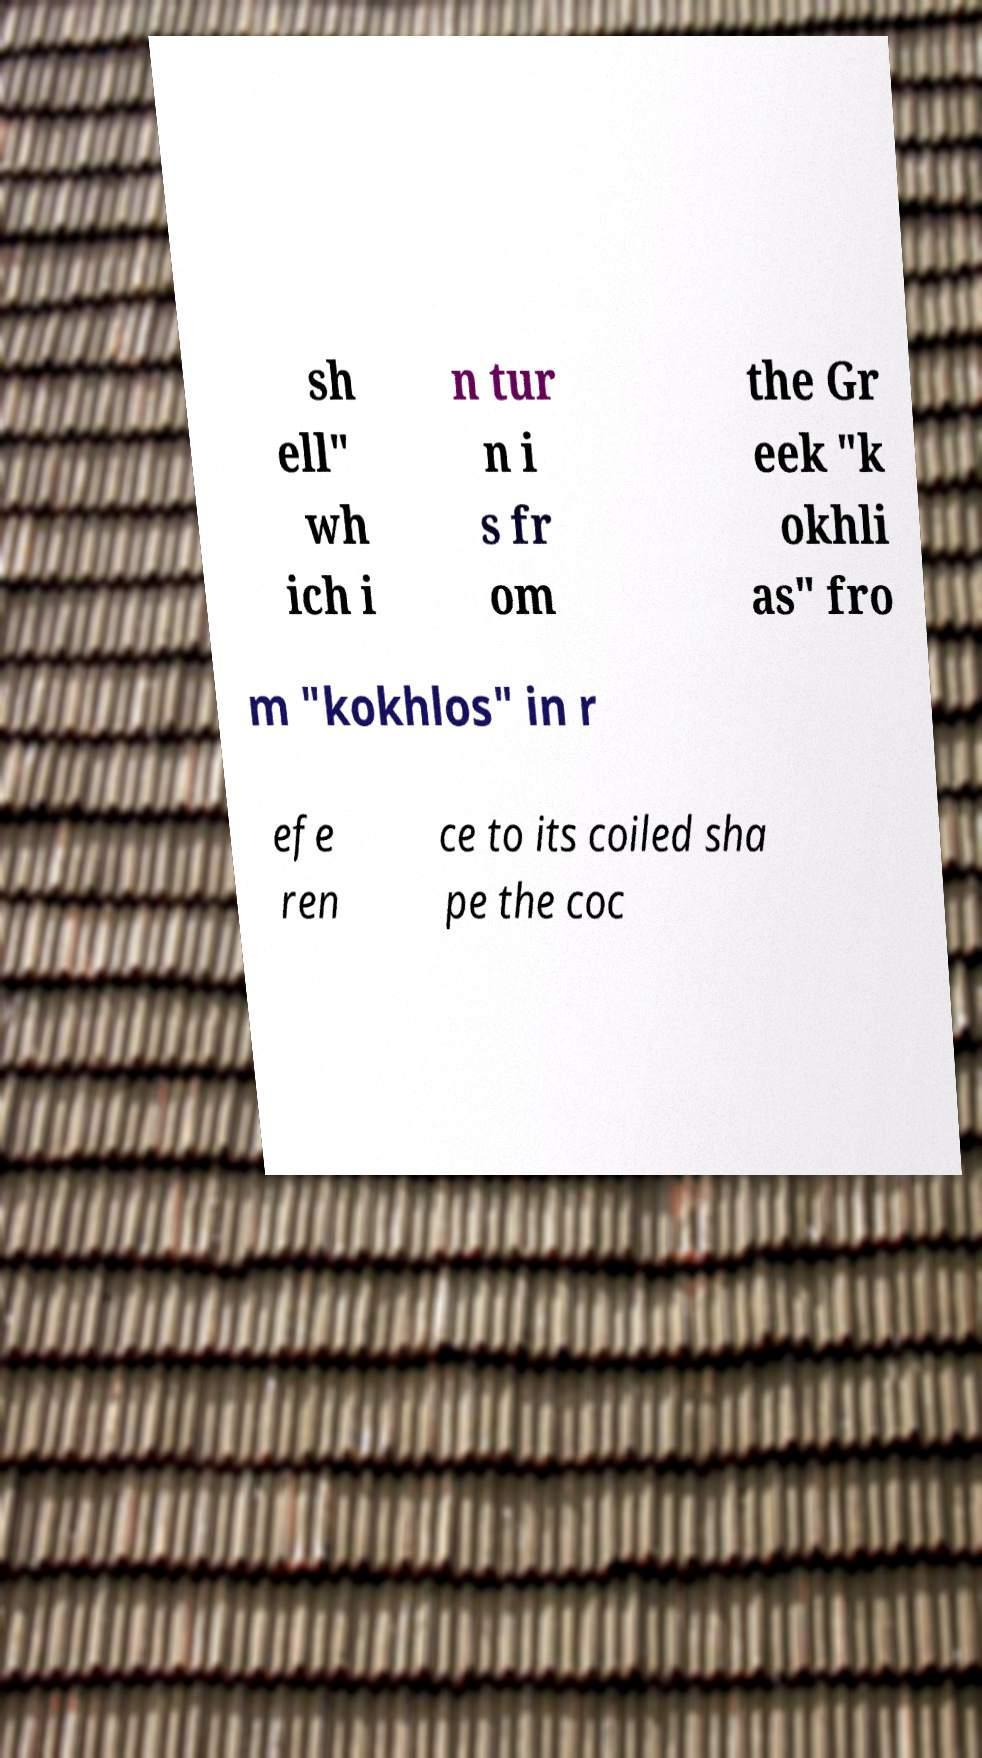Could you assist in decoding the text presented in this image and type it out clearly? sh ell" wh ich i n tur n i s fr om the Gr eek "k okhli as" fro m "kokhlos" in r efe ren ce to its coiled sha pe the coc 